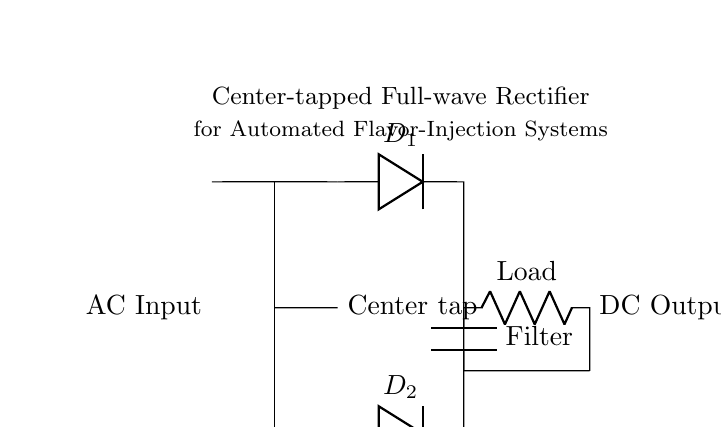What type of rectifier is depicted? The circuit diagram shows a center-tapped full-wave rectifier, indicated by the central tap of the transformer and the two diodes connected to the output circuit.
Answer: center-tapped full-wave rectifier How many diodes are present in the circuit? The circuit contains two diodes, labeled D1 and D2. These are essential for the full-wave rectification process, with each diode conducting during alternate half-cycles of the AC input.
Answer: two What is the function of the filter capacitor? The filter capacitor smooths the output DC voltage by reducing ripples, ensuring a more stable voltage supply to the load. Its placement across the load resistor aids in maintaining steadier voltage levels for the flavor-injection system.
Answer: smooth output Where is the load connected in the circuit? The load is connected across the output terminals, specifically between the point after the capacitor and ground, allowing the controlled DC voltage from the rectifier to energize the flavor-injection system.
Answer: across output terminals If the transformer has a primary voltage of 120 volts, what is the approximate DC output voltage? The output voltage of a center-tapped full-wave rectifier is roughly half of the primary voltage minus the diode forward voltage drops. Assuming ideal conditions and accounting for negligible losses, the output can be estimated to be about 60 volts.
Answer: 60 volts What component is used to prevent current from flowing back into the transformer? The diodes (D1 and D2) function as one-way valves, preventing the reverse flow of current during the negative cycle of the AC input, which is essential for proper rectification.
Answer: diodes What is the purpose of the transformer in this circuit? The transformer steps down the voltage from the AC supply to a lower level suitable for the flavor-injection system, while also providing electrical isolation for safety and reducing voltage levels in accordance with circuit design.
Answer: step down voltage 